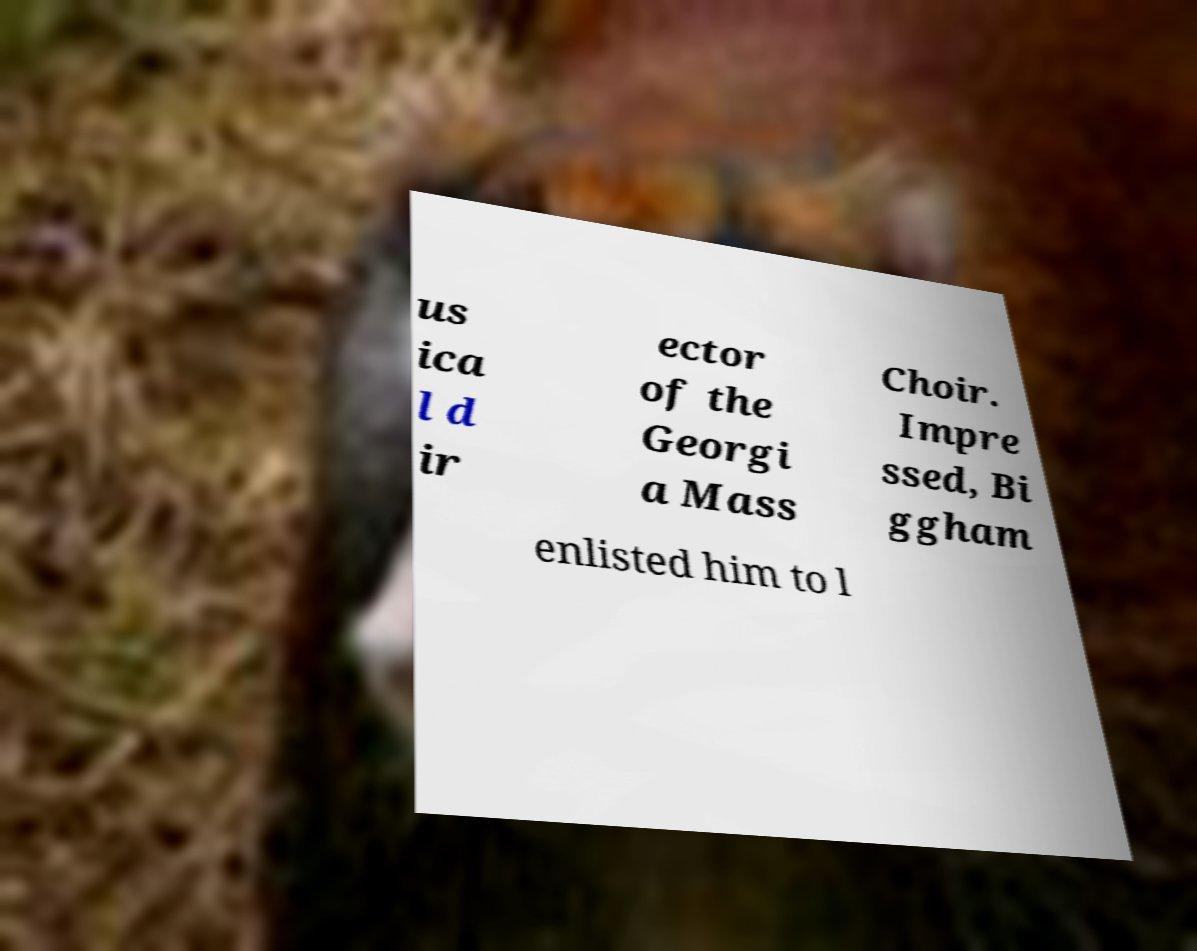Could you extract and type out the text from this image? us ica l d ir ector of the Georgi a Mass Choir. Impre ssed, Bi ggham enlisted him to l 